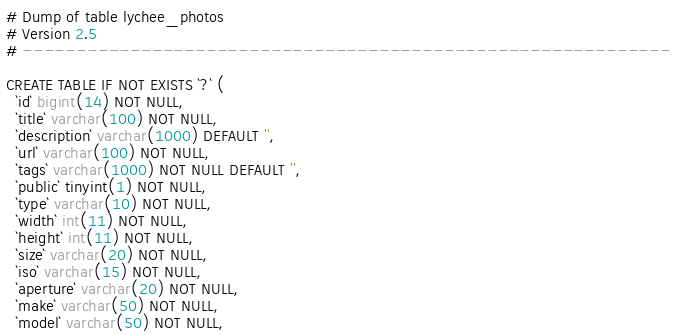<code> <loc_0><loc_0><loc_500><loc_500><_SQL_># Dump of table lychee_photos
# Version 2.5
# ------------------------------------------------------------

CREATE TABLE IF NOT EXISTS `?` (
  `id` bigint(14) NOT NULL,
  `title` varchar(100) NOT NULL,
  `description` varchar(1000) DEFAULT '',
  `url` varchar(100) NOT NULL,
  `tags` varchar(1000) NOT NULL DEFAULT '',
  `public` tinyint(1) NOT NULL,
  `type` varchar(10) NOT NULL,
  `width` int(11) NOT NULL,
  `height` int(11) NOT NULL,
  `size` varchar(20) NOT NULL,
  `iso` varchar(15) NOT NULL,
  `aperture` varchar(20) NOT NULL,
  `make` varchar(50) NOT NULL,
  `model` varchar(50) NOT NULL,</code> 